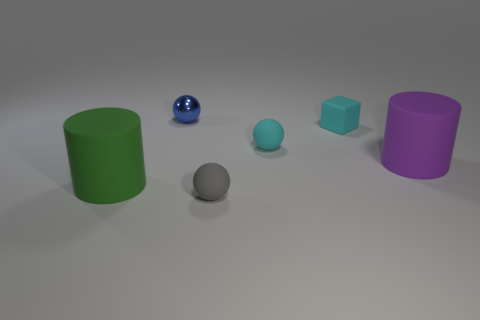Are there any big cylinders that are on the right side of the big object on the right side of the small blue ball? Upon closely examining the image, it appears there are no big cylinders located to the right side of the largest object, which is a purple cylinder on the far right side of the small blue ball. Therefore, the answer is 'no', there are no big cylinders in the specified position. 